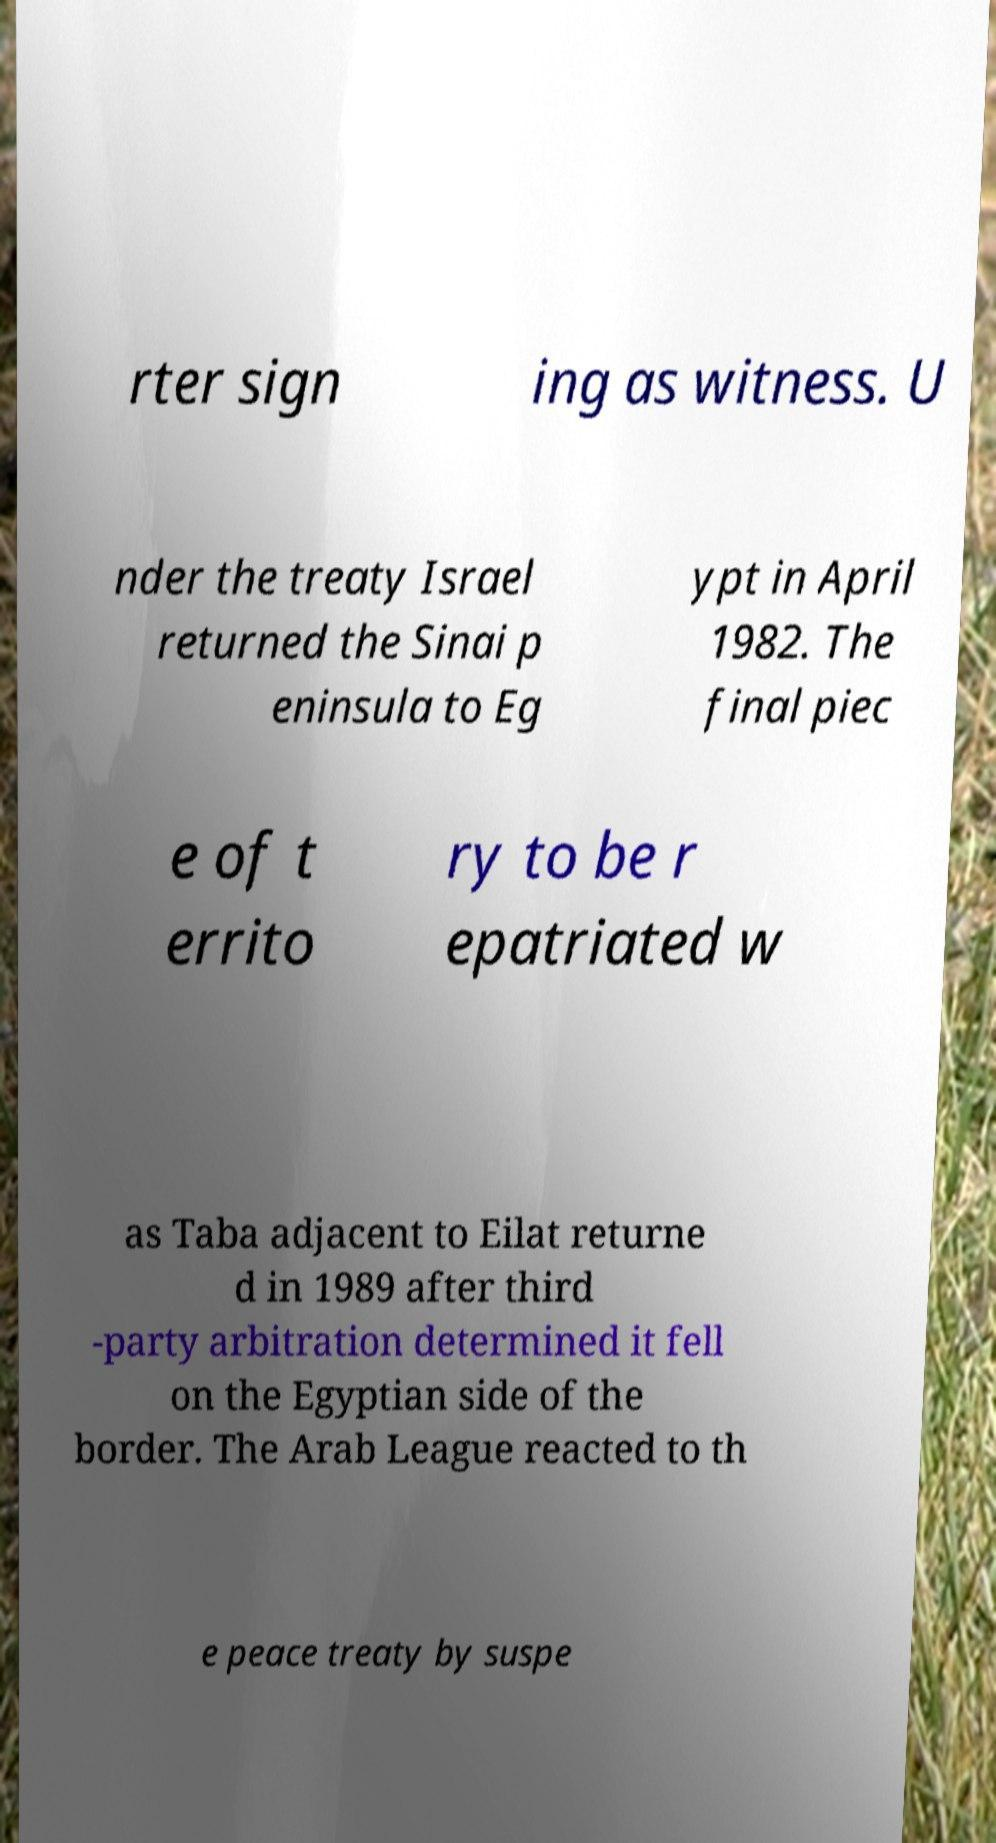There's text embedded in this image that I need extracted. Can you transcribe it verbatim? rter sign ing as witness. U nder the treaty Israel returned the Sinai p eninsula to Eg ypt in April 1982. The final piec e of t errito ry to be r epatriated w as Taba adjacent to Eilat returne d in 1989 after third -party arbitration determined it fell on the Egyptian side of the border. The Arab League reacted to th e peace treaty by suspe 